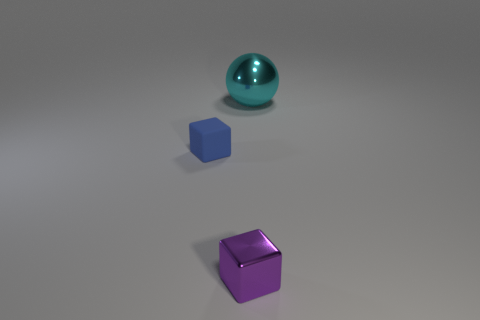Are there any gray shiny spheres of the same size as the blue block?
Ensure brevity in your answer.  No. Is the shape of the blue matte thing the same as the big metallic thing?
Provide a succinct answer. No. There is a tiny block that is in front of the thing to the left of the purple block; is there a purple shiny object that is to the right of it?
Ensure brevity in your answer.  No. What number of other things are the same color as the large metallic thing?
Offer a terse response. 0. Do the shiny object in front of the ball and the cyan object that is behind the small matte object have the same size?
Offer a terse response. No. Are there an equal number of small purple cubes behind the shiny sphere and small rubber cubes in front of the purple object?
Keep it short and to the point. Yes. Are there any other things that have the same material as the tiny blue object?
Keep it short and to the point. No. There is a shiny ball; is it the same size as the metallic thing that is in front of the cyan metal ball?
Offer a terse response. No. There is a thing that is to the left of the cube in front of the rubber thing; what is its material?
Provide a short and direct response. Rubber. Is the number of big metal objects behind the cyan ball the same as the number of small purple metallic objects?
Offer a terse response. No. 